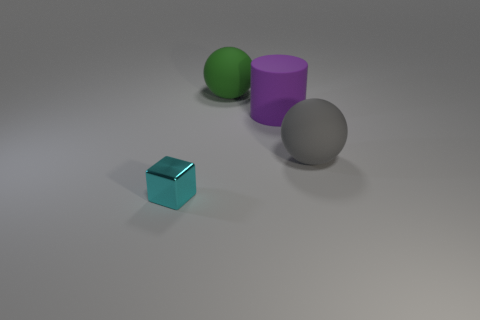Subtract all gray balls. How many balls are left? 1 Add 1 large green matte spheres. How many objects exist? 5 Subtract 1 blocks. How many blocks are left? 0 Subtract 1 cyan blocks. How many objects are left? 3 Subtract all cylinders. How many objects are left? 3 Subtract all red cylinders. Subtract all blue cubes. How many cylinders are left? 1 Subtract all blue balls. How many green cubes are left? 0 Subtract all small green shiny things. Subtract all tiny cyan shiny cubes. How many objects are left? 3 Add 1 matte things. How many matte things are left? 4 Add 4 gray balls. How many gray balls exist? 5 